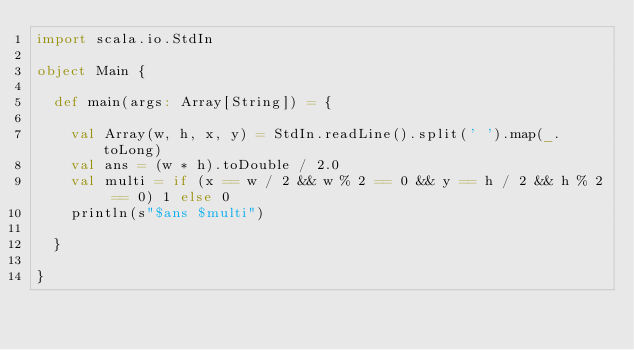Convert code to text. <code><loc_0><loc_0><loc_500><loc_500><_Scala_>import scala.io.StdIn

object Main {

  def main(args: Array[String]) = {

    val Array(w, h, x, y) = StdIn.readLine().split(' ').map(_.toLong)
    val ans = (w * h).toDouble / 2.0
    val multi = if (x == w / 2 && w % 2 == 0 && y == h / 2 && h % 2 == 0) 1 else 0
    println(s"$ans $multi")

  }

}
</code> 